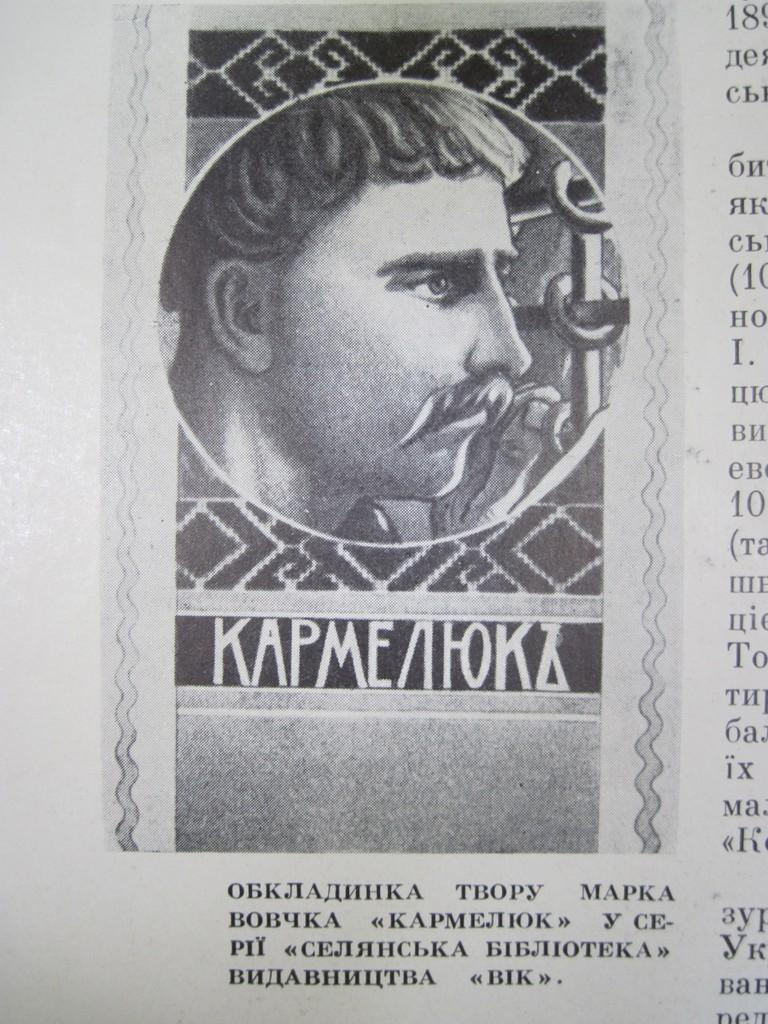What object is present in the image that people use to read news? There is a newspaper in the image. What can be seen in the picture within the newspaper? The newspaper contains a picture of a man. What is used to convey information on the newspaper? There is text written on the newspaper. What type of wool is used to create the man's suit in the picture on the newspaper? There is no information about the man's suit or the type of wool used in the image. 